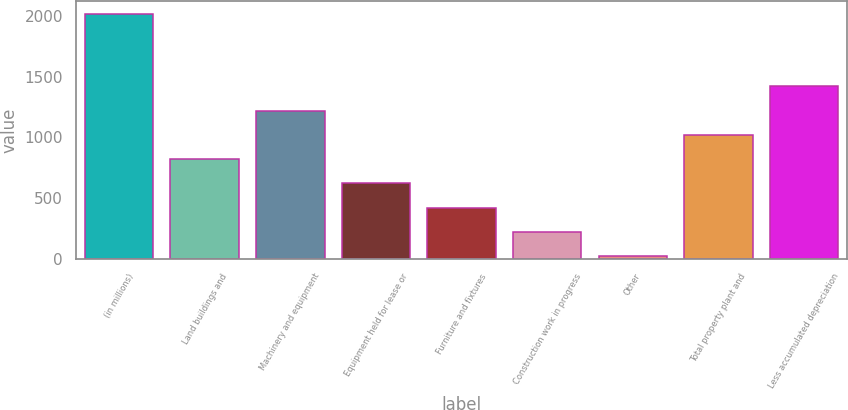<chart> <loc_0><loc_0><loc_500><loc_500><bar_chart><fcel>(in millions)<fcel>Land buildings and<fcel>Machinery and equipment<fcel>Equipment held for lease or<fcel>Furniture and fixtures<fcel>Construction work in progress<fcel>Other<fcel>Total property plant and<fcel>Less accumulated depreciation<nl><fcel>2017<fcel>819.4<fcel>1218.6<fcel>619.8<fcel>420.2<fcel>220.6<fcel>21<fcel>1019<fcel>1418.2<nl></chart> 